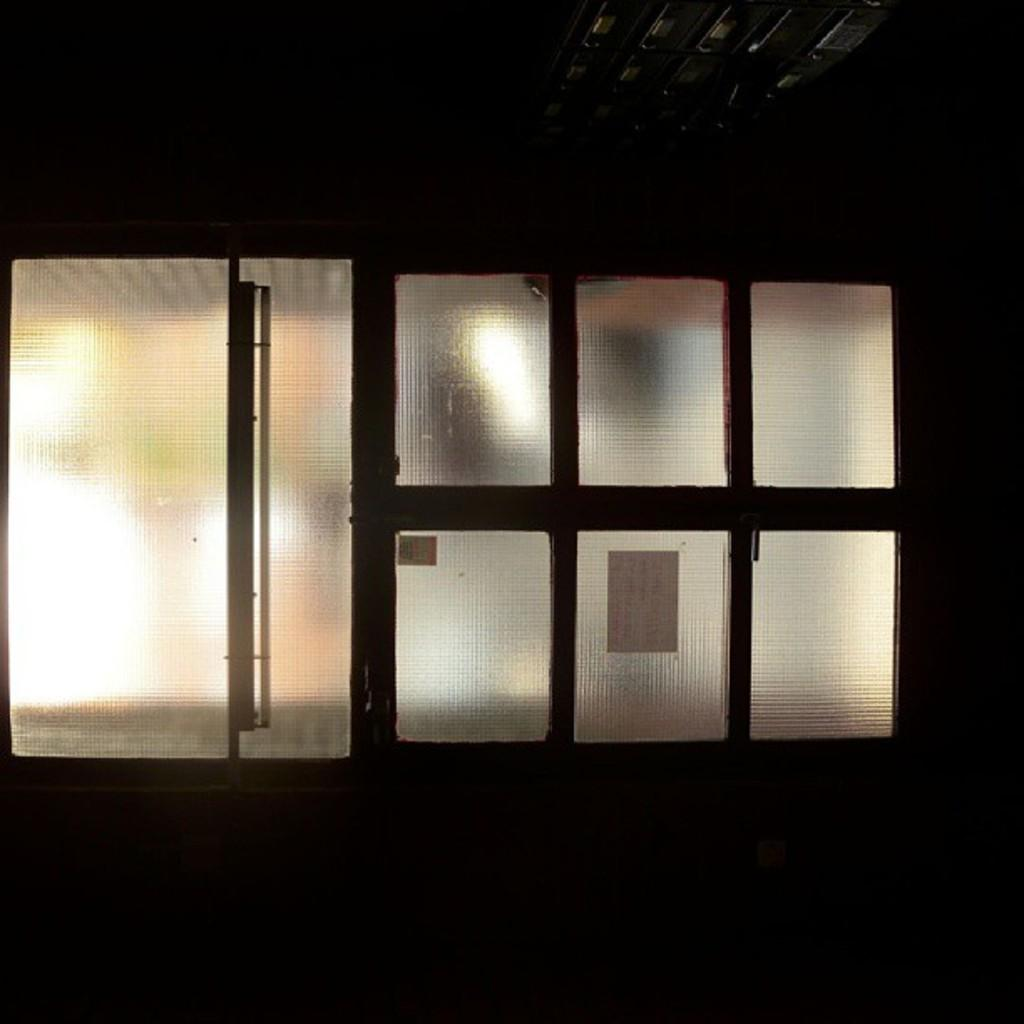What is located in the center of the image? In the center of the image, there is a wall, a roof, glass, a glass door, posters, lights, and other objects. Can you describe the glass in the image? The glass in the center of the image is part of a glass door. What type of posters are present in the image? The posters in the center of the image are not specified, but they are present along with other objects. What kind of lighting is visible in the image? There are lights visible in the center of the image. Where is the curtain located in the image? There is no curtain present in the image. What type of board is visible in the image? There is no board present in the image. 